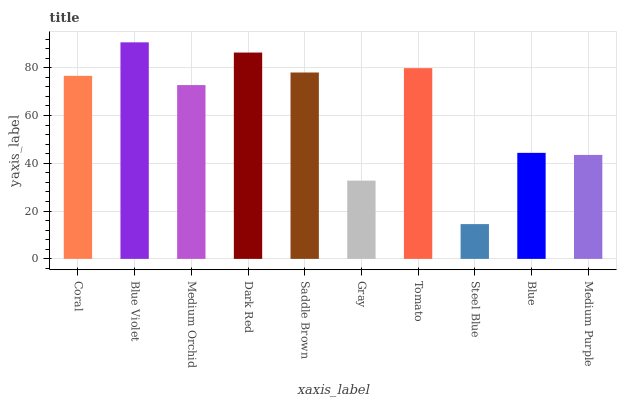Is Steel Blue the minimum?
Answer yes or no. Yes. Is Blue Violet the maximum?
Answer yes or no. Yes. Is Medium Orchid the minimum?
Answer yes or no. No. Is Medium Orchid the maximum?
Answer yes or no. No. Is Blue Violet greater than Medium Orchid?
Answer yes or no. Yes. Is Medium Orchid less than Blue Violet?
Answer yes or no. Yes. Is Medium Orchid greater than Blue Violet?
Answer yes or no. No. Is Blue Violet less than Medium Orchid?
Answer yes or no. No. Is Coral the high median?
Answer yes or no. Yes. Is Medium Orchid the low median?
Answer yes or no. Yes. Is Saddle Brown the high median?
Answer yes or no. No. Is Blue Violet the low median?
Answer yes or no. No. 